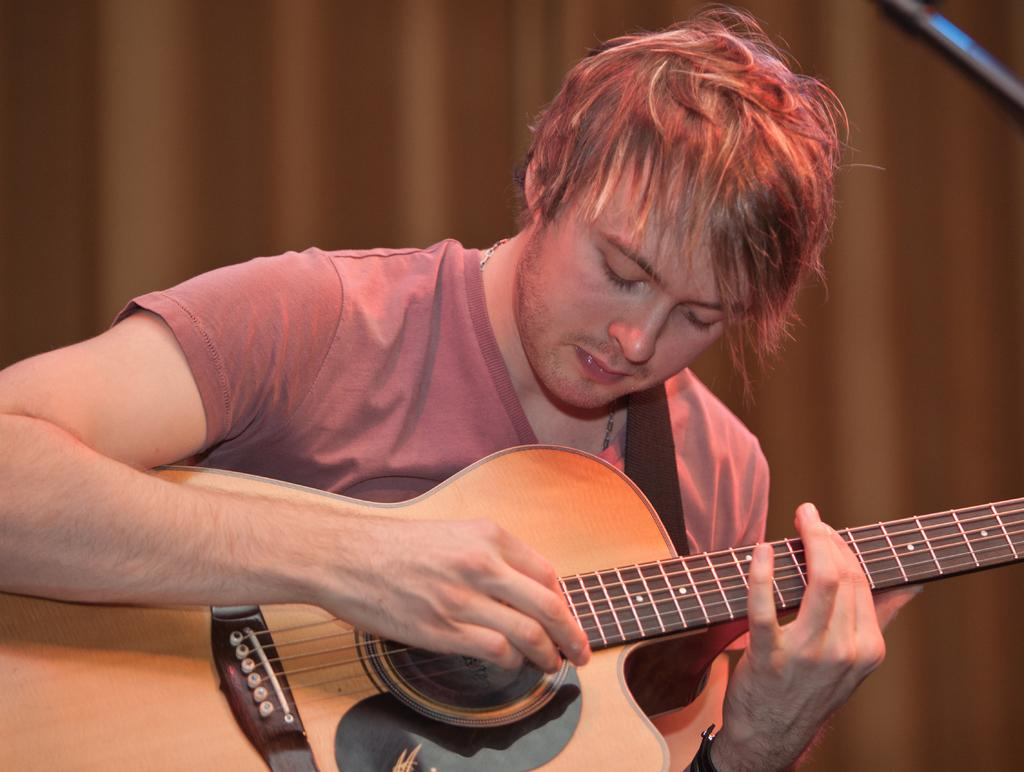What is the main subject of the image? There is a person in the image. What is the person doing in the image? The person is playing the guitar. What type of clothing is the person wearing? The person is wearing a T-shirt. What else can be seen in the background of the image? There is a curtain visible in the image. What type of snow can be seen falling in the image? There is no snow present in the image; it features a person playing the guitar. Who is the creator of the guitar being played in the image? The facts provided do not mention the creator of the guitar, so it cannot be determined from the image. 